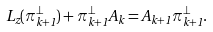<formula> <loc_0><loc_0><loc_500><loc_500>L _ { z } ( \pi _ { k + 1 } ^ { \perp } ) + \pi _ { k + 1 } ^ { \perp } A _ { k } = A _ { k + 1 } \pi _ { k + 1 } ^ { \perp } .</formula> 